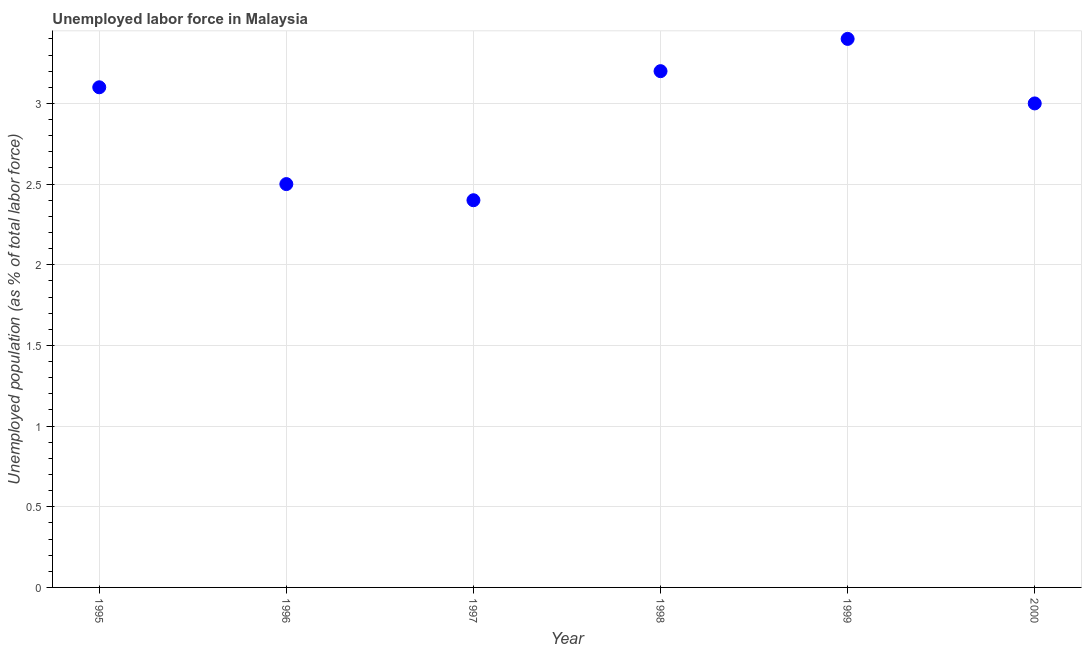What is the total unemployed population in 1999?
Ensure brevity in your answer.  3.4. Across all years, what is the maximum total unemployed population?
Provide a short and direct response. 3.4. Across all years, what is the minimum total unemployed population?
Give a very brief answer. 2.4. In which year was the total unemployed population maximum?
Your answer should be compact. 1999. In which year was the total unemployed population minimum?
Make the answer very short. 1997. What is the sum of the total unemployed population?
Offer a terse response. 17.6. What is the difference between the total unemployed population in 1998 and 2000?
Your answer should be very brief. 0.2. What is the average total unemployed population per year?
Offer a very short reply. 2.93. What is the median total unemployed population?
Offer a very short reply. 3.05. In how many years, is the total unemployed population greater than 2.5 %?
Give a very brief answer. 4. Do a majority of the years between 2000 and 1995 (inclusive) have total unemployed population greater than 0.4 %?
Ensure brevity in your answer.  Yes. What is the ratio of the total unemployed population in 1997 to that in 2000?
Give a very brief answer. 0.8. Is the total unemployed population in 1996 less than that in 1997?
Provide a short and direct response. No. What is the difference between the highest and the second highest total unemployed population?
Your response must be concise. 0.2. Is the sum of the total unemployed population in 1997 and 2000 greater than the maximum total unemployed population across all years?
Offer a very short reply. Yes. What is the difference between the highest and the lowest total unemployed population?
Your response must be concise. 1. In how many years, is the total unemployed population greater than the average total unemployed population taken over all years?
Your response must be concise. 4. Does the graph contain grids?
Your response must be concise. Yes. What is the title of the graph?
Your answer should be compact. Unemployed labor force in Malaysia. What is the label or title of the Y-axis?
Make the answer very short. Unemployed population (as % of total labor force). What is the Unemployed population (as % of total labor force) in 1995?
Give a very brief answer. 3.1. What is the Unemployed population (as % of total labor force) in 1997?
Keep it short and to the point. 2.4. What is the Unemployed population (as % of total labor force) in 1998?
Offer a terse response. 3.2. What is the Unemployed population (as % of total labor force) in 1999?
Give a very brief answer. 3.4. What is the difference between the Unemployed population (as % of total labor force) in 1995 and 1997?
Your answer should be compact. 0.7. What is the difference between the Unemployed population (as % of total labor force) in 1996 and 1998?
Provide a succinct answer. -0.7. What is the difference between the Unemployed population (as % of total labor force) in 1996 and 1999?
Make the answer very short. -0.9. What is the difference between the Unemployed population (as % of total labor force) in 1997 and 1998?
Keep it short and to the point. -0.8. What is the difference between the Unemployed population (as % of total labor force) in 1997 and 2000?
Your answer should be very brief. -0.6. What is the difference between the Unemployed population (as % of total labor force) in 1999 and 2000?
Provide a succinct answer. 0.4. What is the ratio of the Unemployed population (as % of total labor force) in 1995 to that in 1996?
Ensure brevity in your answer.  1.24. What is the ratio of the Unemployed population (as % of total labor force) in 1995 to that in 1997?
Keep it short and to the point. 1.29. What is the ratio of the Unemployed population (as % of total labor force) in 1995 to that in 1998?
Give a very brief answer. 0.97. What is the ratio of the Unemployed population (as % of total labor force) in 1995 to that in 1999?
Keep it short and to the point. 0.91. What is the ratio of the Unemployed population (as % of total labor force) in 1995 to that in 2000?
Give a very brief answer. 1.03. What is the ratio of the Unemployed population (as % of total labor force) in 1996 to that in 1997?
Keep it short and to the point. 1.04. What is the ratio of the Unemployed population (as % of total labor force) in 1996 to that in 1998?
Your answer should be very brief. 0.78. What is the ratio of the Unemployed population (as % of total labor force) in 1996 to that in 1999?
Your response must be concise. 0.73. What is the ratio of the Unemployed population (as % of total labor force) in 1996 to that in 2000?
Give a very brief answer. 0.83. What is the ratio of the Unemployed population (as % of total labor force) in 1997 to that in 1999?
Your answer should be very brief. 0.71. What is the ratio of the Unemployed population (as % of total labor force) in 1998 to that in 1999?
Offer a very short reply. 0.94. What is the ratio of the Unemployed population (as % of total labor force) in 1998 to that in 2000?
Provide a short and direct response. 1.07. What is the ratio of the Unemployed population (as % of total labor force) in 1999 to that in 2000?
Make the answer very short. 1.13. 